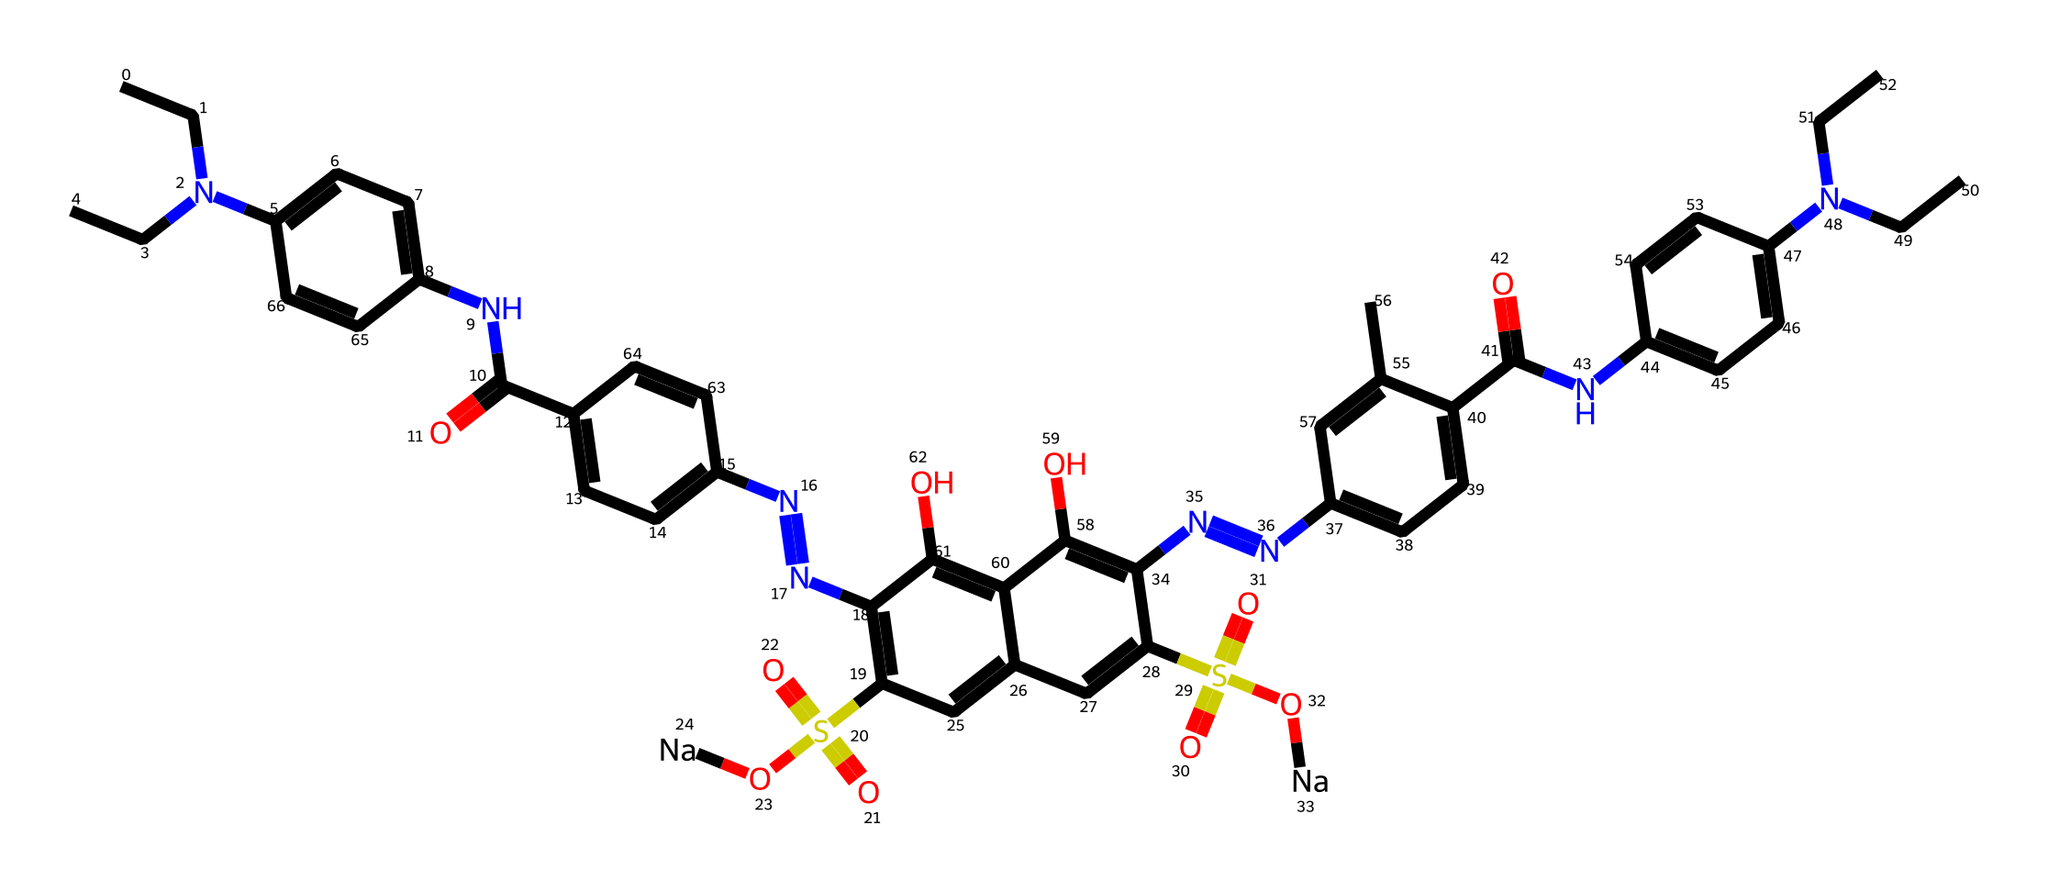what type of chemical is represented by the SMILES? The structure includes aromatic rings and multiple nitrogen atoms, indicating it is a dye. Specifically, it is an artificial food coloring used as a food additive.
Answer: food coloring how many nitrogen atoms are present in the chemical structure? By analyzing the SMILES, we identify four nitrogen (N) atoms that can be counted in the structure. Each nitrogen contributes to the overall structure and functionality of the dye.
Answer: four what functional groups are visible in this compound? The presence of sulfonic acid groups (S(=O)(=O)O) and amine groups (N) can be deduced from the SMILES representation, indicating it has both sulfonic acid and amine functional groups. These contribute to the solubility and color properties of the dye.
Answer: sulfonic acid and amine what is the total number of carbon atoms in the chemical structure? Counting the number of carbon (C) atoms in the SMILES representation shows a total of 32 carbon atoms present in the structure. This count includes those in the aromatic and aliphatic portions of the molecule.
Answer: thirty-two which part of the molecule determines its solubility in water? The sulfonic acid groups (S(=O)(=O)O) introduce polarity and charge, which enhances water solubility for the dye. This property is crucial for the dye’s application in food products such as jello.
Answer: sulfonic acid groups how does the presence of azo groups affect the coloring properties? The azo groups (N=N) create a strong color due to the delocalization of electrons, which absorbs visible light. This characteristic is fundamental for artificial dyes, influencing the coloration seen in food like jello.
Answer: color intensity 